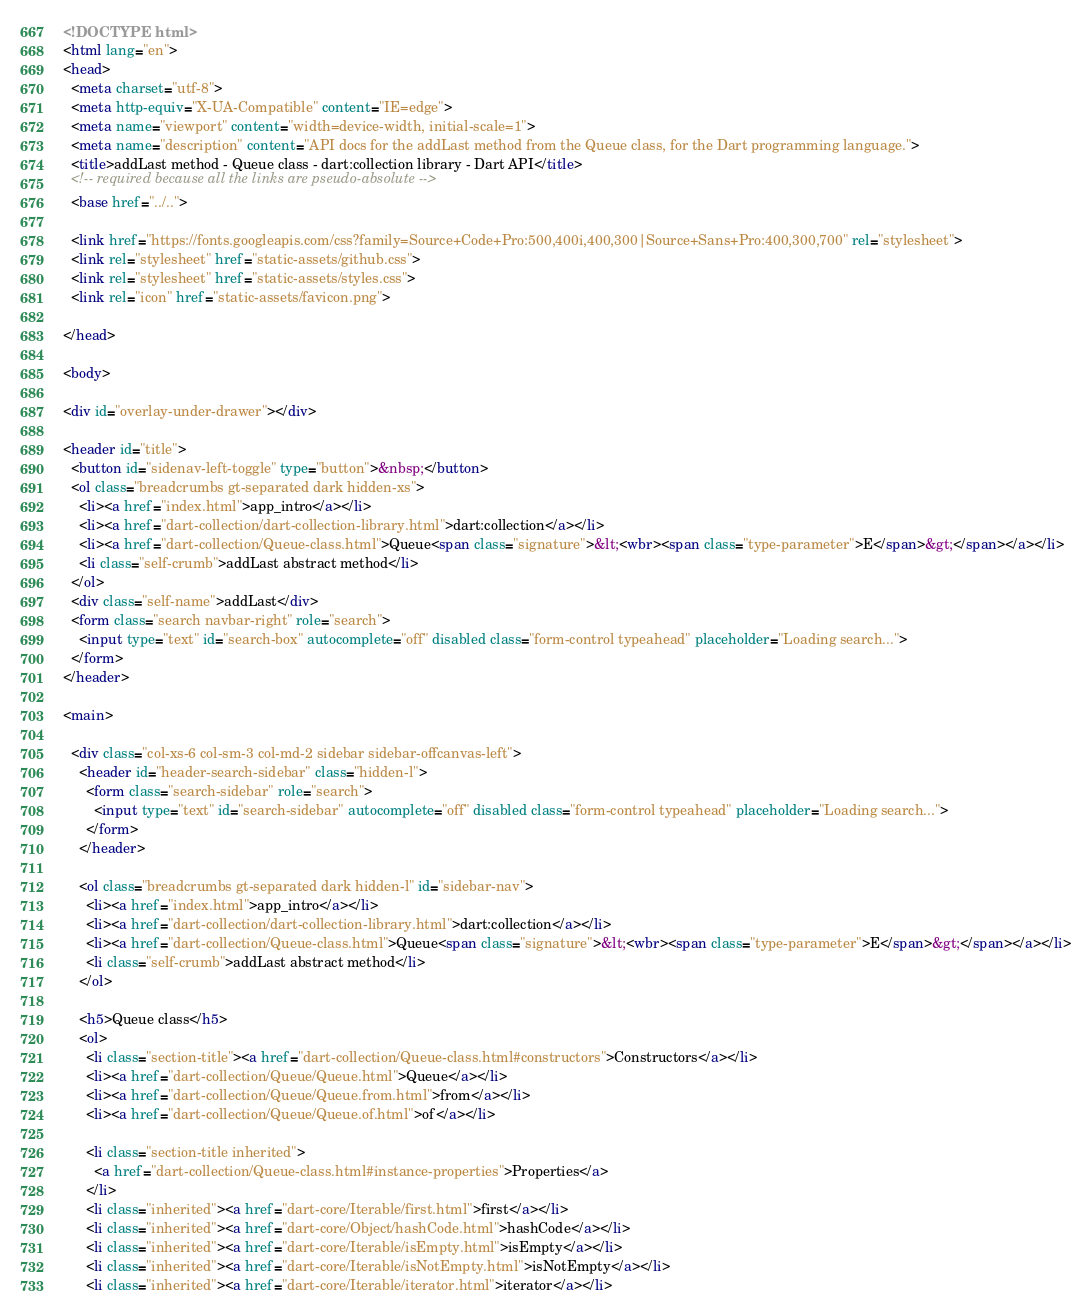<code> <loc_0><loc_0><loc_500><loc_500><_HTML_><!DOCTYPE html>
<html lang="en">
<head>
  <meta charset="utf-8">
  <meta http-equiv="X-UA-Compatible" content="IE=edge">
  <meta name="viewport" content="width=device-width, initial-scale=1">
  <meta name="description" content="API docs for the addLast method from the Queue class, for the Dart programming language.">
  <title>addLast method - Queue class - dart:collection library - Dart API</title>
  <!-- required because all the links are pseudo-absolute -->
  <base href="../..">

  <link href="https://fonts.googleapis.com/css?family=Source+Code+Pro:500,400i,400,300|Source+Sans+Pro:400,300,700" rel="stylesheet">
  <link rel="stylesheet" href="static-assets/github.css">
  <link rel="stylesheet" href="static-assets/styles.css">
  <link rel="icon" href="static-assets/favicon.png">
  
</head>

<body>

<div id="overlay-under-drawer"></div>

<header id="title">
  <button id="sidenav-left-toggle" type="button">&nbsp;</button>
  <ol class="breadcrumbs gt-separated dark hidden-xs">
    <li><a href="index.html">app_intro</a></li>
    <li><a href="dart-collection/dart-collection-library.html">dart:collection</a></li>
    <li><a href="dart-collection/Queue-class.html">Queue<span class="signature">&lt;<wbr><span class="type-parameter">E</span>&gt;</span></a></li>
    <li class="self-crumb">addLast abstract method</li>
  </ol>
  <div class="self-name">addLast</div>
  <form class="search navbar-right" role="search">
    <input type="text" id="search-box" autocomplete="off" disabled class="form-control typeahead" placeholder="Loading search...">
  </form>
</header>

<main>

  <div class="col-xs-6 col-sm-3 col-md-2 sidebar sidebar-offcanvas-left">
    <header id="header-search-sidebar" class="hidden-l">
      <form class="search-sidebar" role="search">
        <input type="text" id="search-sidebar" autocomplete="off" disabled class="form-control typeahead" placeholder="Loading search...">
      </form>
    </header>
    
    <ol class="breadcrumbs gt-separated dark hidden-l" id="sidebar-nav">
      <li><a href="index.html">app_intro</a></li>
      <li><a href="dart-collection/dart-collection-library.html">dart:collection</a></li>
      <li><a href="dart-collection/Queue-class.html">Queue<span class="signature">&lt;<wbr><span class="type-parameter">E</span>&gt;</span></a></li>
      <li class="self-crumb">addLast abstract method</li>
    </ol>
    
    <h5>Queue class</h5>
    <ol>
      <li class="section-title"><a href="dart-collection/Queue-class.html#constructors">Constructors</a></li>
      <li><a href="dart-collection/Queue/Queue.html">Queue</a></li>
      <li><a href="dart-collection/Queue/Queue.from.html">from</a></li>
      <li><a href="dart-collection/Queue/Queue.of.html">of</a></li>
    
      <li class="section-title inherited">
        <a href="dart-collection/Queue-class.html#instance-properties">Properties</a>
      </li>
      <li class="inherited"><a href="dart-core/Iterable/first.html">first</a></li>
      <li class="inherited"><a href="dart-core/Object/hashCode.html">hashCode</a></li>
      <li class="inherited"><a href="dart-core/Iterable/isEmpty.html">isEmpty</a></li>
      <li class="inherited"><a href="dart-core/Iterable/isNotEmpty.html">isNotEmpty</a></li>
      <li class="inherited"><a href="dart-core/Iterable/iterator.html">iterator</a></li></code> 